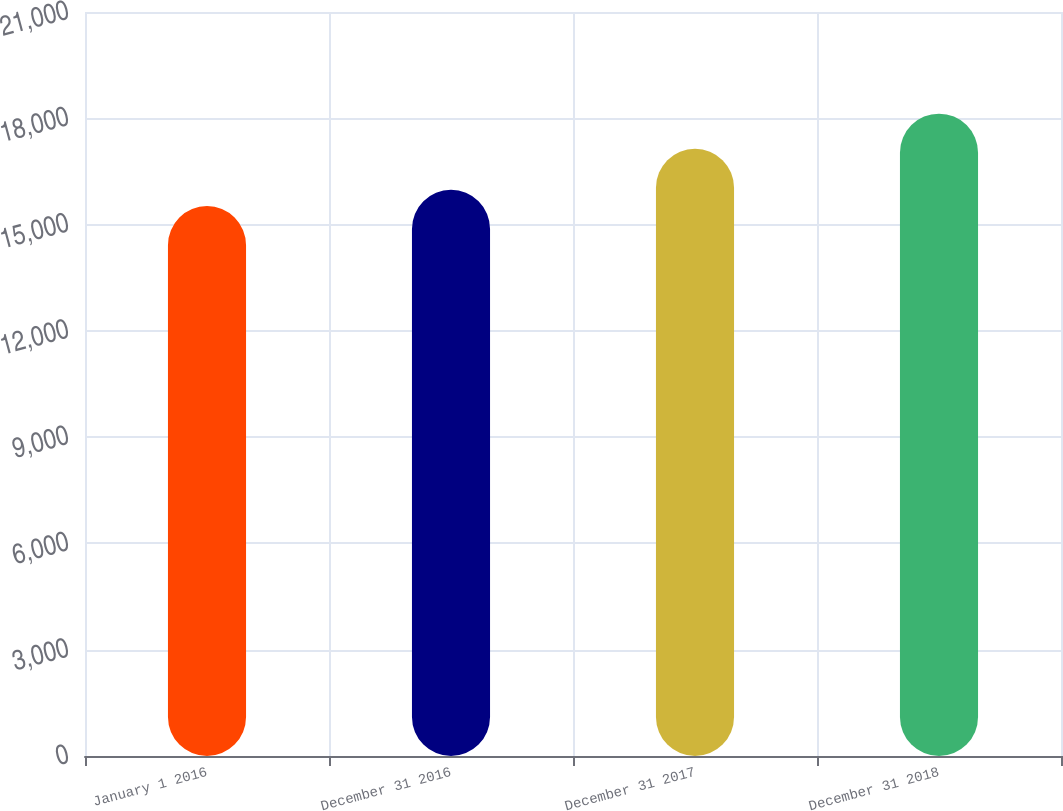Convert chart. <chart><loc_0><loc_0><loc_500><loc_500><bar_chart><fcel>January 1 2016<fcel>December 31 2016<fcel>December 31 2017<fcel>December 31 2018<nl><fcel>15521<fcel>15980<fcel>17140<fcel>18131<nl></chart> 